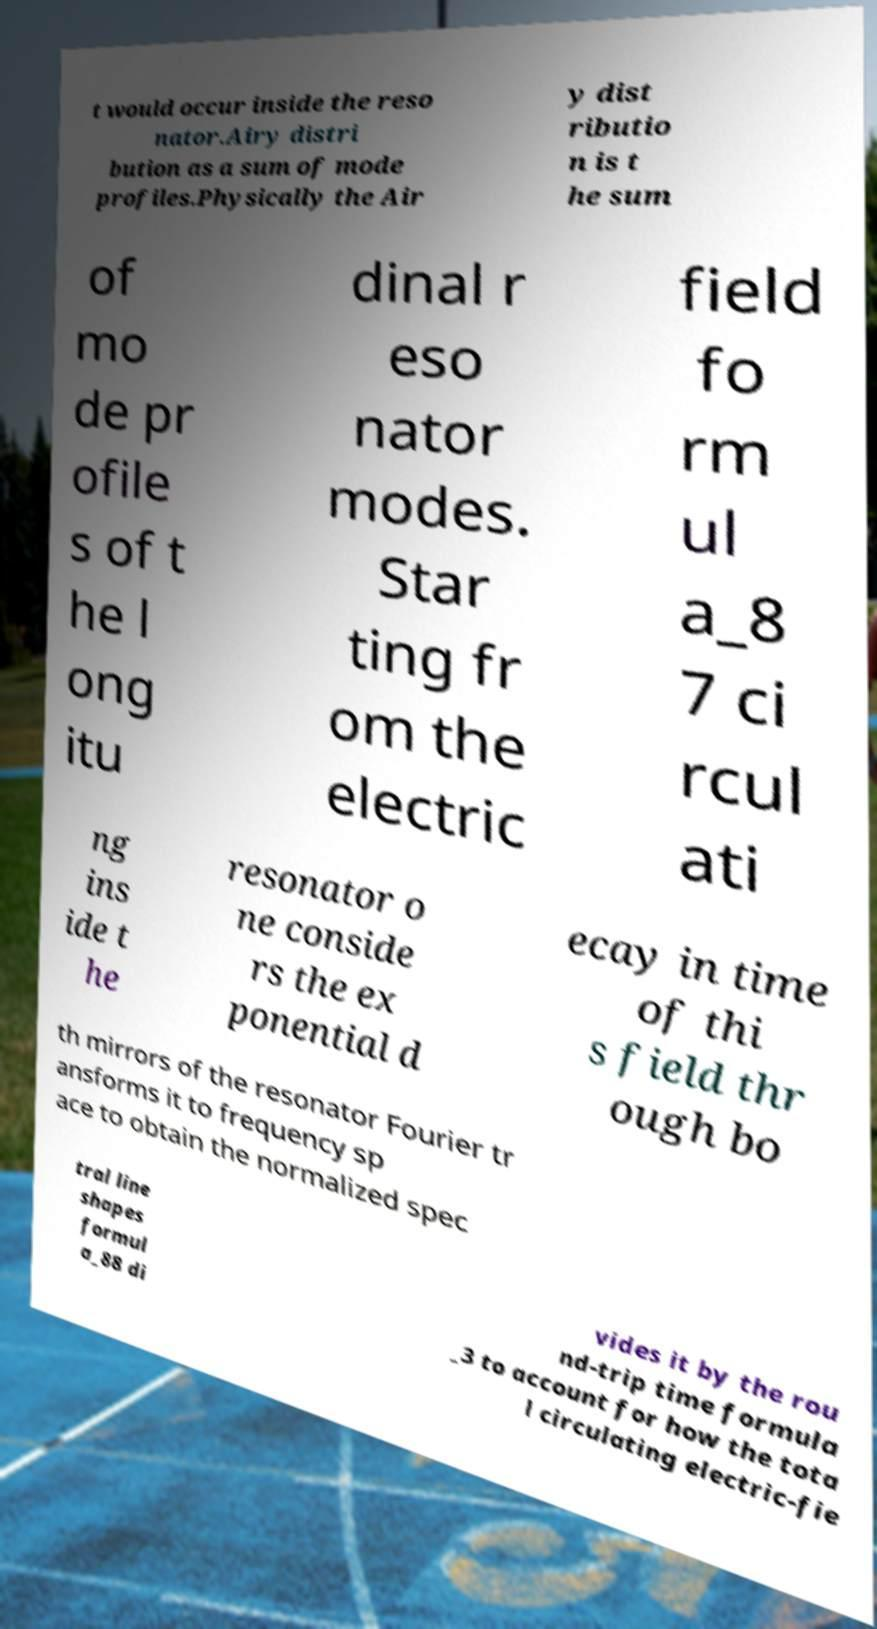There's text embedded in this image that I need extracted. Can you transcribe it verbatim? t would occur inside the reso nator.Airy distri bution as a sum of mode profiles.Physically the Air y dist ributio n is t he sum of mo de pr ofile s of t he l ong itu dinal r eso nator modes. Star ting fr om the electric field fo rm ul a_8 7 ci rcul ati ng ins ide t he resonator o ne conside rs the ex ponential d ecay in time of thi s field thr ough bo th mirrors of the resonator Fourier tr ansforms it to frequency sp ace to obtain the normalized spec tral line shapes formul a_88 di vides it by the rou nd-trip time formula _3 to account for how the tota l circulating electric-fie 